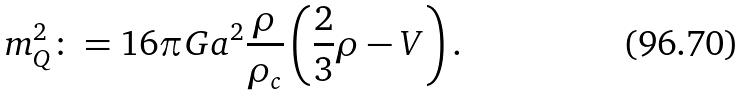<formula> <loc_0><loc_0><loc_500><loc_500>m ^ { 2 } _ { Q } \colon = 1 6 \pi G a ^ { 2 } \frac { \rho } { \rho _ { c } } \left ( \frac { 2 } { 3 } \rho - V \right ) .</formula> 